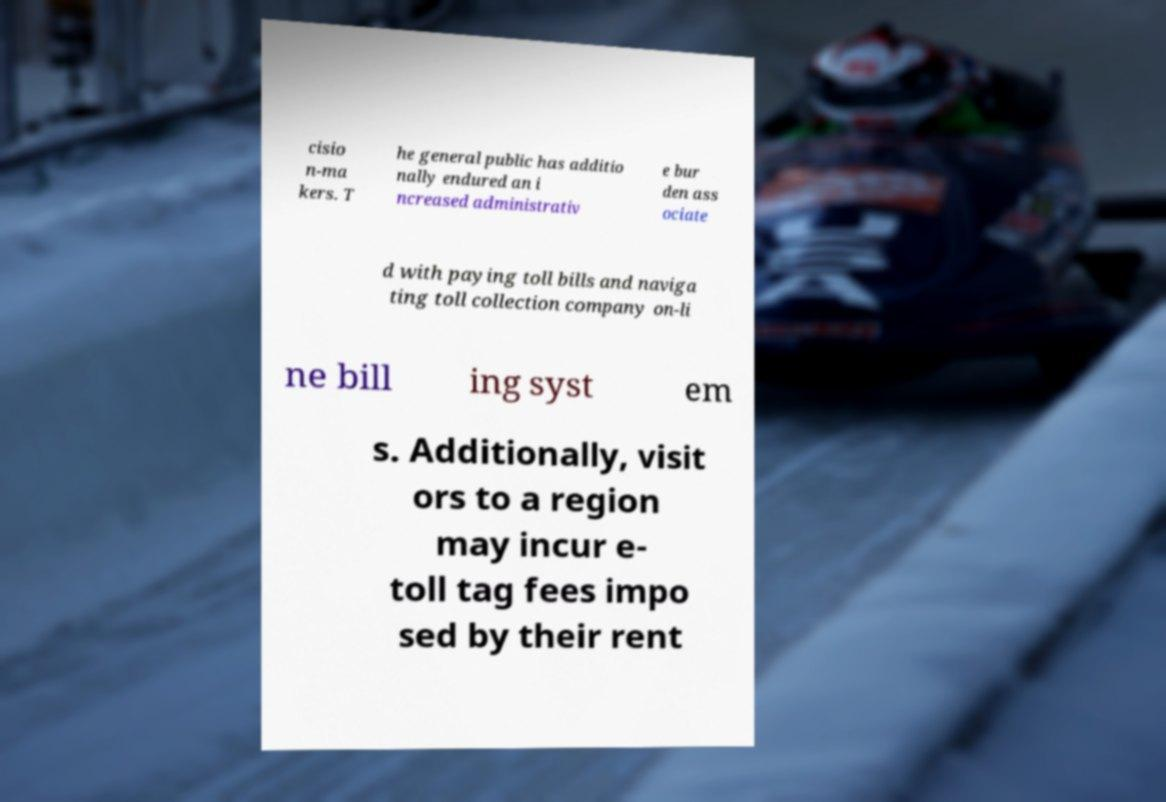There's text embedded in this image that I need extracted. Can you transcribe it verbatim? cisio n-ma kers. T he general public has additio nally endured an i ncreased administrativ e bur den ass ociate d with paying toll bills and naviga ting toll collection company on-li ne bill ing syst em s. Additionally, visit ors to a region may incur e- toll tag fees impo sed by their rent 